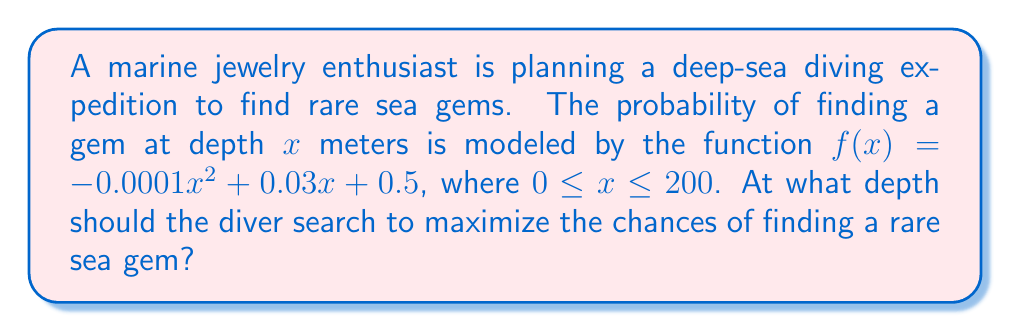Solve this math problem. To find the optimal depth for maximizing the probability of finding a rare sea gem, we need to determine the maximum point of the given function $f(x) = -0.0001x^2 + 0.03x + 0.5$.

Step 1: Find the derivative of $f(x)$.
$$f'(x) = -0.0002x + 0.03$$

Step 2: Set the derivative equal to zero and solve for $x$.
$$\begin{align}
-0.0002x + 0.03 &= 0 \\
-0.0002x &= -0.03 \\
x &= \frac{-0.03}{-0.0002} = 150
\end{align}$$

Step 3: Verify that this critical point is a maximum by checking the second derivative.
$$f''(x) = -0.0002$$

Since $f''(x)$ is negative, the critical point at $x = 150$ is indeed a maximum.

Step 4: Check the endpoint at $x = 200$ to ensure it's not higher than the found maximum.
$$f(150) = -0.0001(150)^2 + 0.03(150) + 0.5 = 2.75$$
$$f(200) = -0.0001(200)^2 + 0.03(200) + 0.5 = 2.5$$

The value at $x = 150$ is higher, confirming it is the global maximum within the given range.

Therefore, the optimal depth for finding rare sea gems is 150 meters.
Answer: 150 meters 